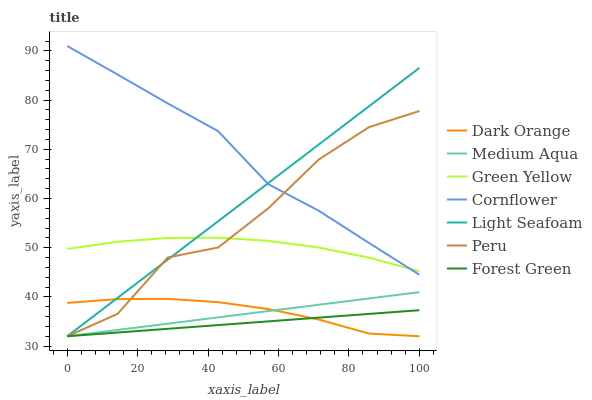Does Forest Green have the minimum area under the curve?
Answer yes or no. Yes. Does Cornflower have the maximum area under the curve?
Answer yes or no. Yes. Does Light Seafoam have the minimum area under the curve?
Answer yes or no. No. Does Light Seafoam have the maximum area under the curve?
Answer yes or no. No. Is Forest Green the smoothest?
Answer yes or no. Yes. Is Peru the roughest?
Answer yes or no. Yes. Is Light Seafoam the smoothest?
Answer yes or no. No. Is Light Seafoam the roughest?
Answer yes or no. No. Does Dark Orange have the lowest value?
Answer yes or no. Yes. Does Cornflower have the lowest value?
Answer yes or no. No. Does Cornflower have the highest value?
Answer yes or no. Yes. Does Light Seafoam have the highest value?
Answer yes or no. No. Is Medium Aqua less than Green Yellow?
Answer yes or no. Yes. Is Cornflower greater than Medium Aqua?
Answer yes or no. Yes. Does Dark Orange intersect Medium Aqua?
Answer yes or no. Yes. Is Dark Orange less than Medium Aqua?
Answer yes or no. No. Is Dark Orange greater than Medium Aqua?
Answer yes or no. No. Does Medium Aqua intersect Green Yellow?
Answer yes or no. No. 